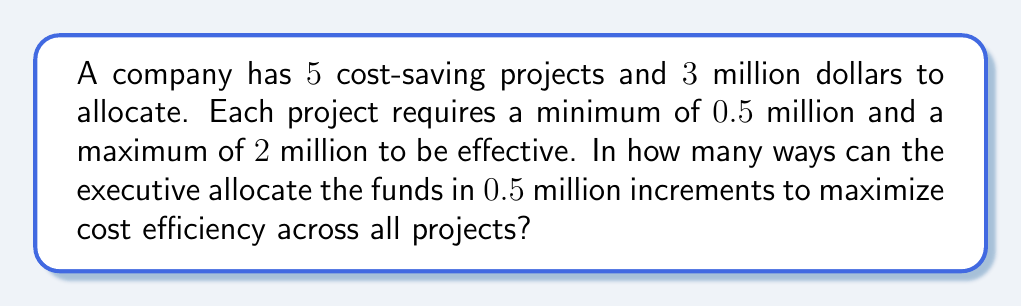What is the answer to this math problem? Let's approach this step-by-step:

1) First, we need to determine how many $0.5$ million units we have:
   $\frac{3 \text{ million}}{0.5 \text{ million per unit}} = 6 \text{ units}$

2) We need to distribute these 6 units among 5 projects, with each project receiving at least 1 unit and at most 4 units.

3) This is a classic stars and bars problem with restrictions. We can use the concept of generating functions to solve this.

4) Let $x_i$ represent the number of units allocated to project $i$. We need to find the number of solutions to:

   $x_1 + x_2 + x_3 + x_4 + x_5 = 6$

   where $1 \leq x_i \leq 4$ for all $i$.

5) The generating function for each $x_i$ is:

   $f(t) = t + t^2 + t^3 + t^4$

6) The generating function for the whole problem is:

   $F(t) = (t + t^2 + t^3 + t^4)^5$

7) We need to find the coefficient of $t^6$ in this expansion.

8) Expanding this manually would be tedious, so we can use the inclusion-exclusion principle:

   $$\binom{6+5-1}{5-1} - \binom{5}{1}\binom{6-5+5-1}{5-1} + \binom{5}{2}\binom{6-10+5-1}{5-1} = 126 - 50 + 0 = 76$$

   Here, $\binom{6+5-1}{5-1}$ represents all ways to distribute 6 units among 5 projects,
   $\binom{5}{1}\binom{6-5+5-1}{5-1}$ subtracts cases where one project gets 5 units,
   and $\binom{5}{2}\binom{6-10+5-1}{5-1}$ adds back cases where two projects each get 5 units (which is 0 in this case).
Answer: 76 